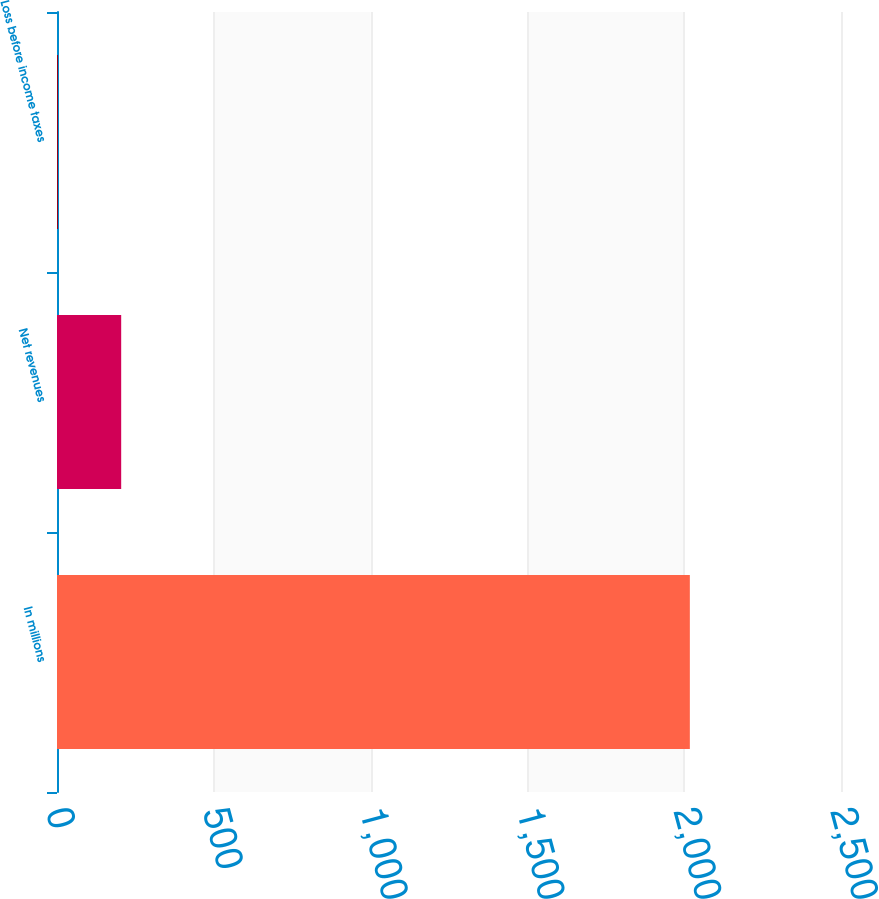Convert chart to OTSL. <chart><loc_0><loc_0><loc_500><loc_500><bar_chart><fcel>In millions<fcel>Net revenues<fcel>Loss before income taxes<nl><fcel>2018<fcel>204.68<fcel>3.2<nl></chart> 